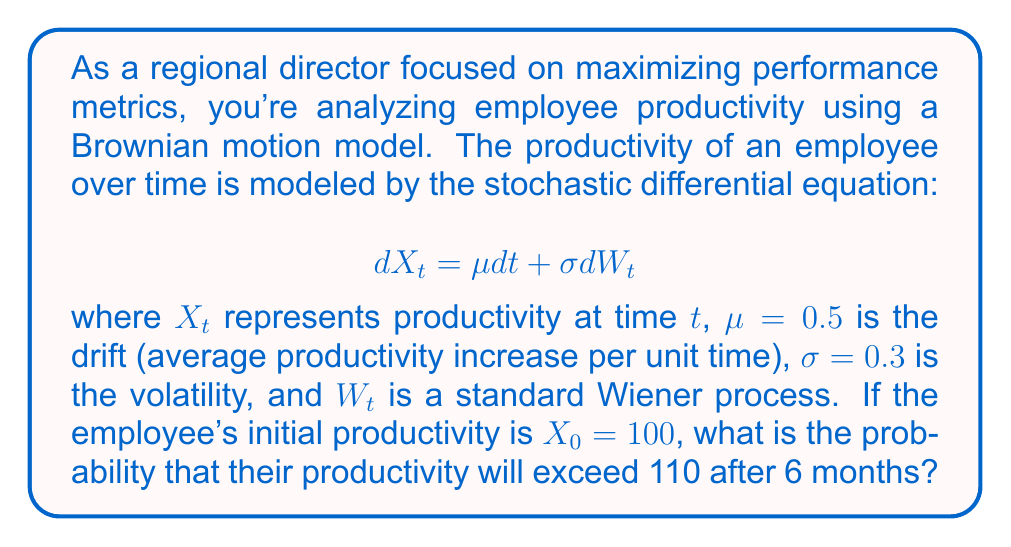Can you solve this math problem? To solve this problem, we'll follow these steps:

1) For Brownian motion with drift, we know that $X_t$ follows a normal distribution with mean and variance:

   $E[X_t] = X_0 + \mu t$
   $Var(X_t) = \sigma^2 t$

2) Calculate the mean after 6 months (t = 0.5 years):
   $E[X_{0.5}] = 100 + 0.5 * 0.5 = 100.25$

3) Calculate the variance after 6 months:
   $Var(X_{0.5}) = 0.3^2 * 0.5 = 0.045$

4) The standard deviation is the square root of the variance:
   $SD = \sqrt{0.045} = 0.212$

5) We want to find $P(X_{0.5} > 110)$. We can standardize this to a Z-score:

   $Z = \frac{110 - 100.25}{0.212} = 45.99$

6) The probability is then:
   $P(X_{0.5} > 110) = 1 - \Phi(45.99)$

   where $\Phi$ is the cumulative distribution function of the standard normal distribution.

7) Using a standard normal table or calculator, we find:
   $1 - \Phi(45.99) \approx 0$

This extremely small probability is due to the large difference between the target (110) and the expected value (100.25) relative to the small standard deviation.
Answer: $P(X_{0.5} > 110) \approx 0$ 